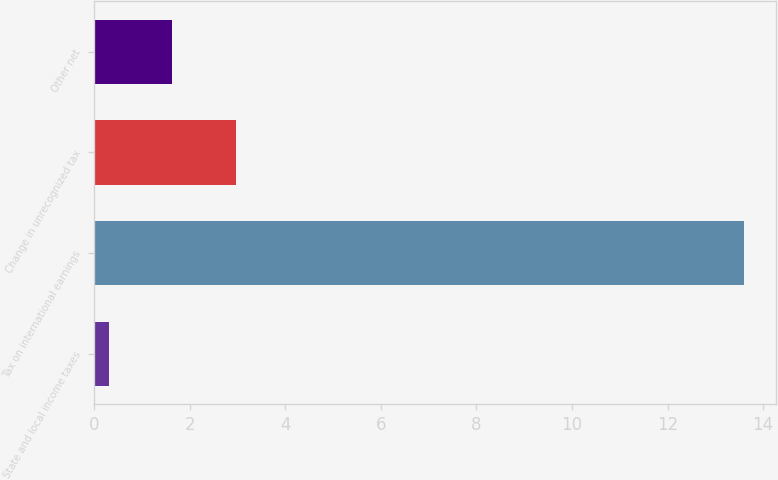<chart> <loc_0><loc_0><loc_500><loc_500><bar_chart><fcel>State and local income taxes<fcel>Tax on international earnings<fcel>Change in unrecognized tax<fcel>Other net<nl><fcel>0.3<fcel>13.6<fcel>2.96<fcel>1.63<nl></chart> 